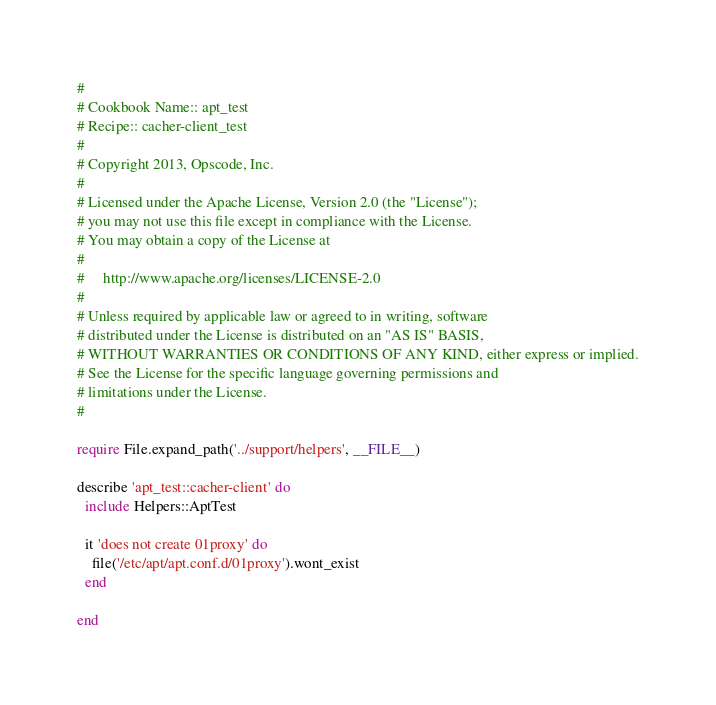Convert code to text. <code><loc_0><loc_0><loc_500><loc_500><_Ruby_>#
# Cookbook Name:: apt_test
# Recipe:: cacher-client_test
#
# Copyright 2013, Opscode, Inc.
#
# Licensed under the Apache License, Version 2.0 (the "License");
# you may not use this file except in compliance with the License.
# You may obtain a copy of the License at
#
#     http://www.apache.org/licenses/LICENSE-2.0
#
# Unless required by applicable law or agreed to in writing, software
# distributed under the License is distributed on an "AS IS" BASIS,
# WITHOUT WARRANTIES OR CONDITIONS OF ANY KIND, either express or implied.
# See the License for the specific language governing permissions and
# limitations under the License.
#

require File.expand_path('../support/helpers', __FILE__)

describe 'apt_test::cacher-client' do
  include Helpers::AptTest

  it 'does not create 01proxy' do
    file('/etc/apt/apt.conf.d/01proxy').wont_exist
  end

end
</code> 